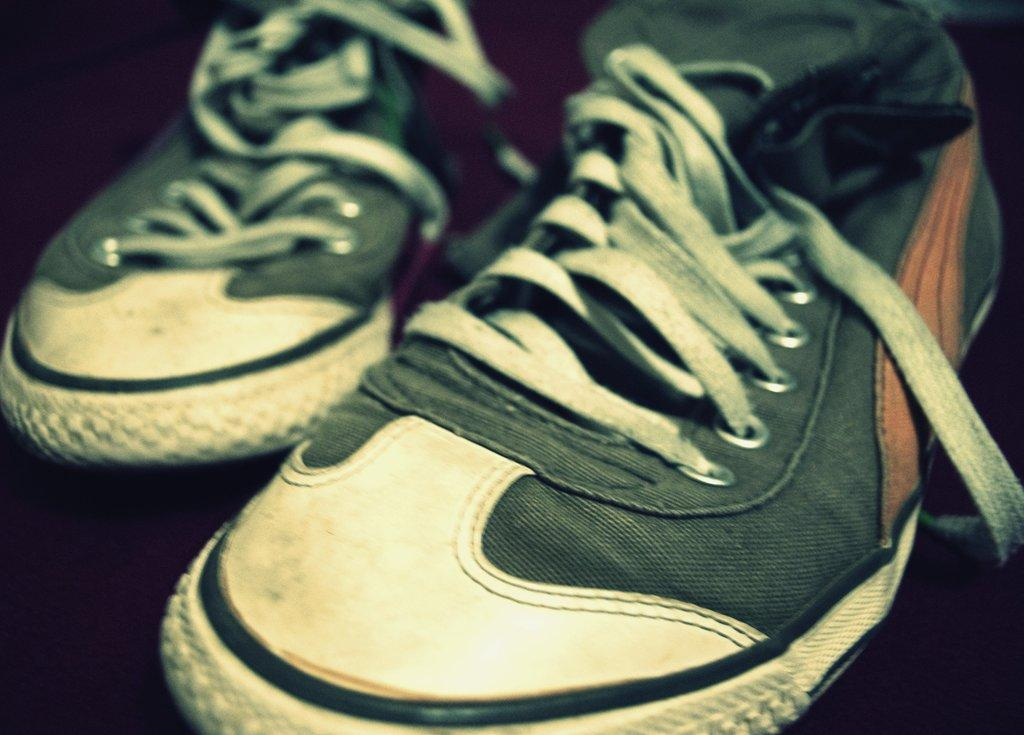What type of object is present in the image? There is a pair of shoes in the image. What type of flowers can be seen growing out of the shoes in the image? There are no flowers growing out of the shoes in the image; it only features a pair of shoes. 